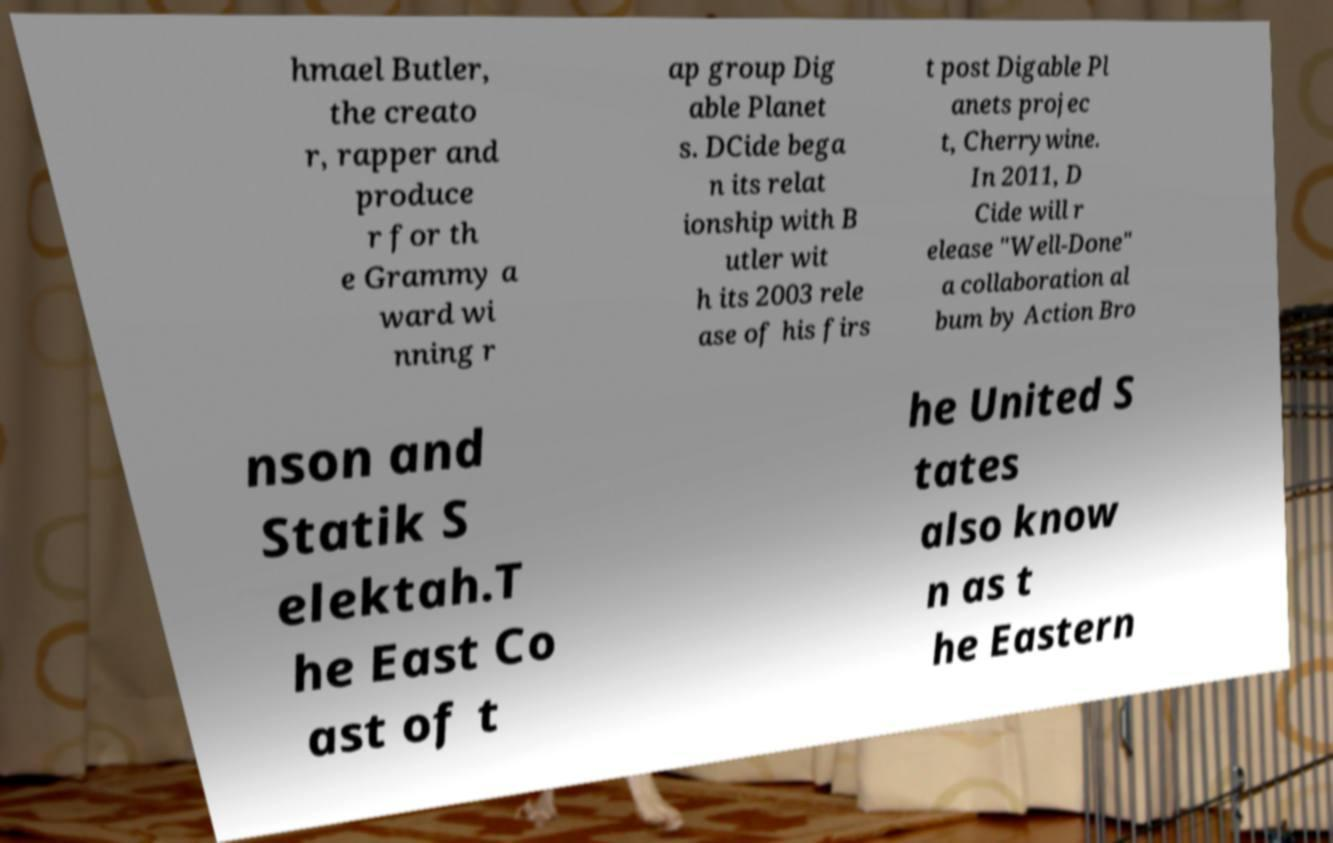What messages or text are displayed in this image? I need them in a readable, typed format. hmael Butler, the creato r, rapper and produce r for th e Grammy a ward wi nning r ap group Dig able Planet s. DCide bega n its relat ionship with B utler wit h its 2003 rele ase of his firs t post Digable Pl anets projec t, Cherrywine. In 2011, D Cide will r elease "Well-Done" a collaboration al bum by Action Bro nson and Statik S elektah.T he East Co ast of t he United S tates also know n as t he Eastern 